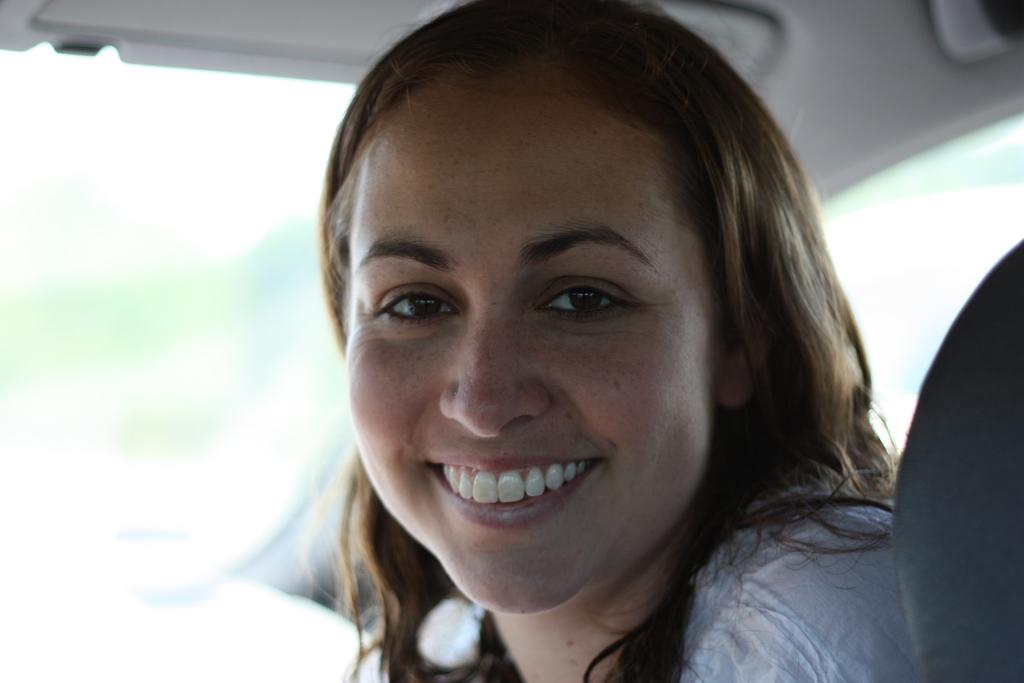Who is the main subject in the image? There is a woman in the image. What is the woman doing in the image? The woman is sitting on a seat. Where is the seat located? The seat is inside a vehicle. How close is the vehicle to the viewer of the image? The vehicle is in the foreground of the image. What is the smell of the vehicle in the image? The image does not provide any information about the smell of the vehicle, so it cannot be determined. 